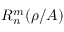Convert formula to latex. <formula><loc_0><loc_0><loc_500><loc_500>R _ { n } ^ { m } ( \rho / A )</formula> 